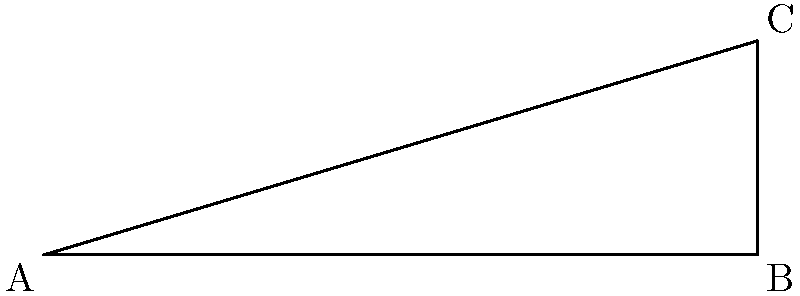As you contemplate the spiritual journey ahead, you're preparing to lead a pilgrimage to a sacred mountain. The base of the mountain is 5000 meters from your starting point, and its peak rises 1500 meters above the ground. What is the angle of elevation ($\theta$) to the top of the sacred mountain from your starting point? Round your answer to the nearest degree. Let's approach this step-by-step:

1) We can use trigonometry to solve this problem. The situation forms a right-angled triangle where:
   - The adjacent side is the distance to the base of the mountain (5000 m)
   - The opposite side is the height of the mountain (1500 m)
   - The angle we're looking for is the angle of elevation ($\theta$)

2) In a right-angled triangle, tangent of an angle is the ratio of the opposite side to the adjacent side:

   $$\tan(\theta) = \frac{\text{opposite}}{\text{adjacent}}$$

3) Substituting our values:

   $$\tan(\theta) = \frac{1500}{5000}$$

4) To find $\theta$, we need to use the inverse tangent (arctan or $\tan^{-1}$):

   $$\theta = \tan^{-1}\left(\frac{1500}{5000}\right)$$

5) Using a calculator:

   $$\theta = \tan^{-1}(0.3) \approx 16.70^\circ$$

6) Rounding to the nearest degree:

   $$\theta \approx 17^\circ$$

This angle represents the spiritual ascent you and your followers will undertake, symbolizing the elevation of the soul towards higher truths.
Answer: $17^\circ$ 